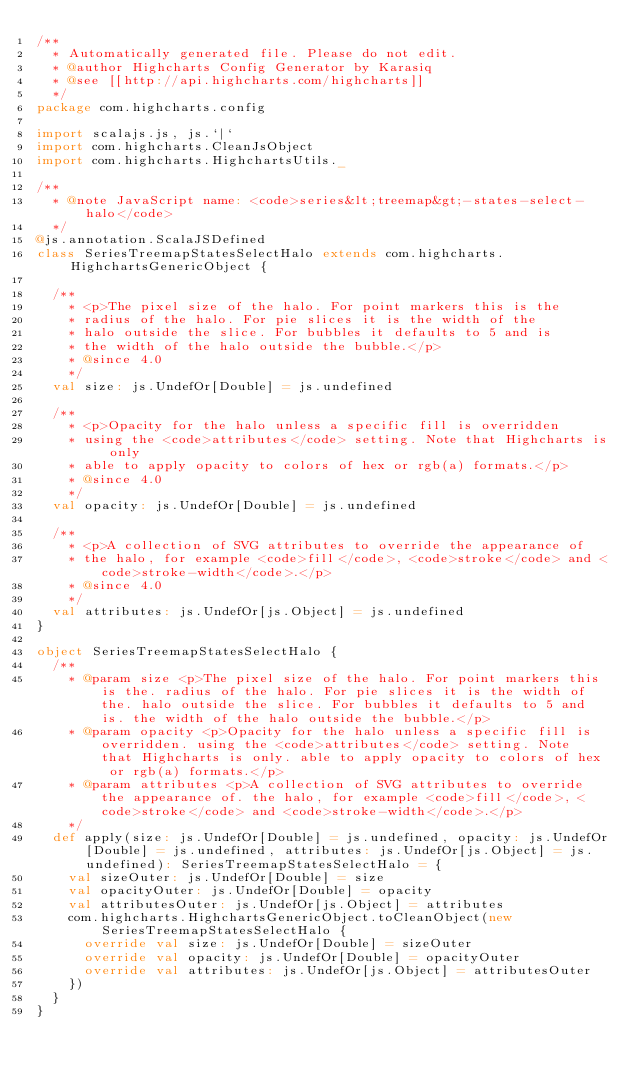<code> <loc_0><loc_0><loc_500><loc_500><_Scala_>/**
  * Automatically generated file. Please do not edit.
  * @author Highcharts Config Generator by Karasiq
  * @see [[http://api.highcharts.com/highcharts]]
  */
package com.highcharts.config

import scalajs.js, js.`|`
import com.highcharts.CleanJsObject
import com.highcharts.HighchartsUtils._

/**
  * @note JavaScript name: <code>series&lt;treemap&gt;-states-select-halo</code>
  */
@js.annotation.ScalaJSDefined
class SeriesTreemapStatesSelectHalo extends com.highcharts.HighchartsGenericObject {

  /**
    * <p>The pixel size of the halo. For point markers this is the
    * radius of the halo. For pie slices it is the width of the
    * halo outside the slice. For bubbles it defaults to 5 and is
    * the width of the halo outside the bubble.</p>
    * @since 4.0
    */
  val size: js.UndefOr[Double] = js.undefined

  /**
    * <p>Opacity for the halo unless a specific fill is overridden
    * using the <code>attributes</code> setting. Note that Highcharts is only
    * able to apply opacity to colors of hex or rgb(a) formats.</p>
    * @since 4.0
    */
  val opacity: js.UndefOr[Double] = js.undefined

  /**
    * <p>A collection of SVG attributes to override the appearance of
    * the halo, for example <code>fill</code>, <code>stroke</code> and <code>stroke-width</code>.</p>
    * @since 4.0
    */
  val attributes: js.UndefOr[js.Object] = js.undefined
}

object SeriesTreemapStatesSelectHalo {
  /**
    * @param size <p>The pixel size of the halo. For point markers this is the. radius of the halo. For pie slices it is the width of the. halo outside the slice. For bubbles it defaults to 5 and is. the width of the halo outside the bubble.</p>
    * @param opacity <p>Opacity for the halo unless a specific fill is overridden. using the <code>attributes</code> setting. Note that Highcharts is only. able to apply opacity to colors of hex or rgb(a) formats.</p>
    * @param attributes <p>A collection of SVG attributes to override the appearance of. the halo, for example <code>fill</code>, <code>stroke</code> and <code>stroke-width</code>.</p>
    */
  def apply(size: js.UndefOr[Double] = js.undefined, opacity: js.UndefOr[Double] = js.undefined, attributes: js.UndefOr[js.Object] = js.undefined): SeriesTreemapStatesSelectHalo = {
    val sizeOuter: js.UndefOr[Double] = size
    val opacityOuter: js.UndefOr[Double] = opacity
    val attributesOuter: js.UndefOr[js.Object] = attributes
    com.highcharts.HighchartsGenericObject.toCleanObject(new SeriesTreemapStatesSelectHalo {
      override val size: js.UndefOr[Double] = sizeOuter
      override val opacity: js.UndefOr[Double] = opacityOuter
      override val attributes: js.UndefOr[js.Object] = attributesOuter
    })
  }
}
</code> 